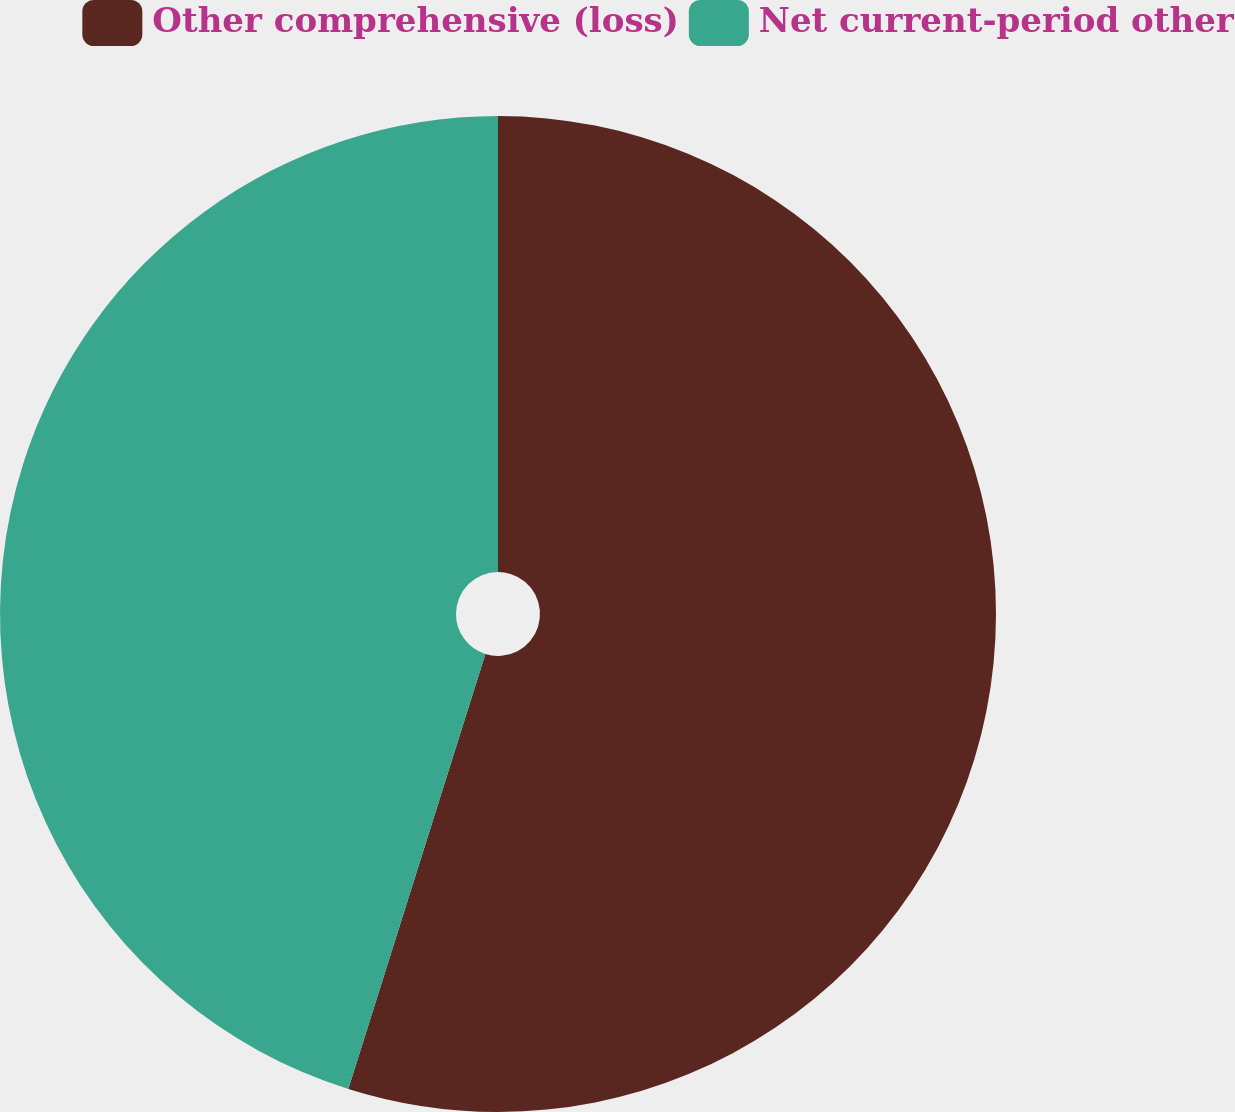Convert chart. <chart><loc_0><loc_0><loc_500><loc_500><pie_chart><fcel>Other comprehensive (loss)<fcel>Net current-period other<nl><fcel>54.86%<fcel>45.14%<nl></chart> 